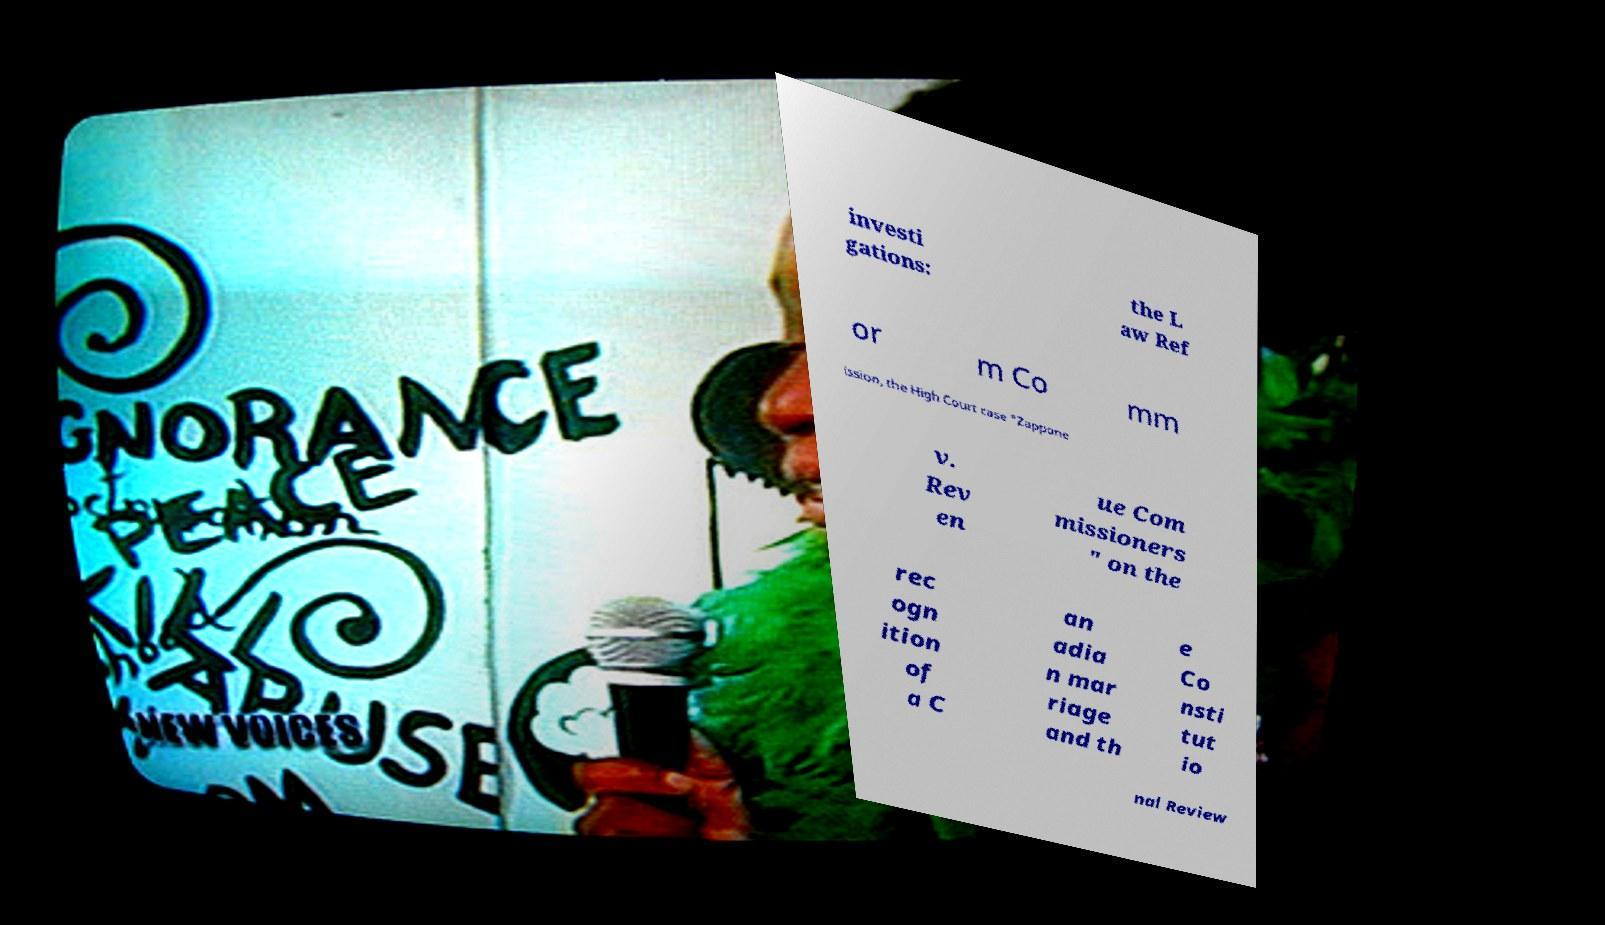There's text embedded in this image that I need extracted. Can you transcribe it verbatim? investi gations: the L aw Ref or m Co mm ission, the High Court case "Zappone v. Rev en ue Com missioners " on the rec ogn ition of a C an adia n mar riage and th e Co nsti tut io nal Review 